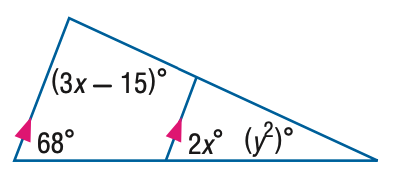Question: Find y in the figure.
Choices:
A. 5
B. 6
C. 25
D. 36
Answer with the letter. Answer: A 